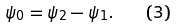<formula> <loc_0><loc_0><loc_500><loc_500>\psi _ { 0 } = \psi _ { 2 } - \psi _ { 1 } . \quad ( 3 )</formula> 